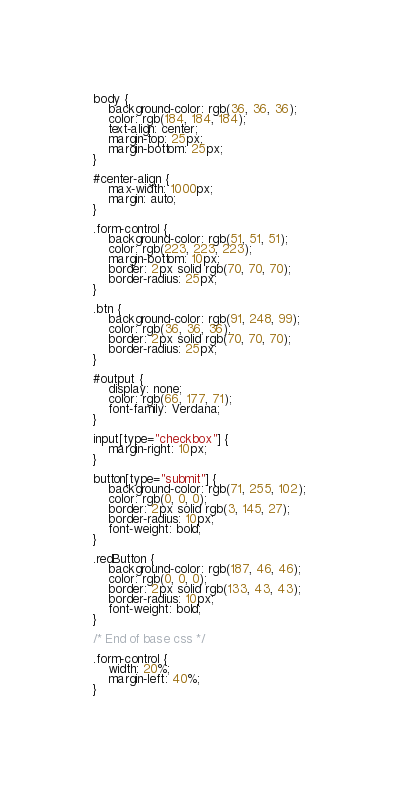<code> <loc_0><loc_0><loc_500><loc_500><_CSS_>body {
	background-color: rgb(36, 36, 36);
	color: rgb(184, 184, 184);
	text-align: center;
	margin-top: 25px;
	margin-bottom: 25px;
}

#center-align {
	max-width: 1000px;
	margin: auto;
}

.form-control {
	background-color: rgb(51, 51, 51);
	color: rgb(223, 223, 223);
	margin-bottom: 10px;
	border: 2px solid rgb(70, 70, 70);
	border-radius: 25px;
}

.btn {
	background-color: rgb(91, 248, 99);
	color: rgb(36, 36, 36);
	border: 2px solid rgb(70, 70, 70);
	border-radius: 25px;
}

#output {
	display: none;
	color: rgb(66, 177, 71);
	font-family: Verdana;
}

input[type="checkbox"] {
	margin-right: 10px;
}

button[type="submit"] {
	background-color: rgb(71, 255, 102);
	color: rgb(0, 0, 0);
	border: 2px solid rgb(3, 145, 27);
	border-radius: 10px;
	font-weight: bold;
}

.redButton {
	background-color: rgb(187, 46, 46);
	color: rgb(0, 0, 0);
	border: 2px solid rgb(133, 43, 43);
	border-radius: 10px;
	font-weight: bold;
}

/* End of base css */

.form-control {
	width: 20%;
	margin-left: 40%;
}
</code> 